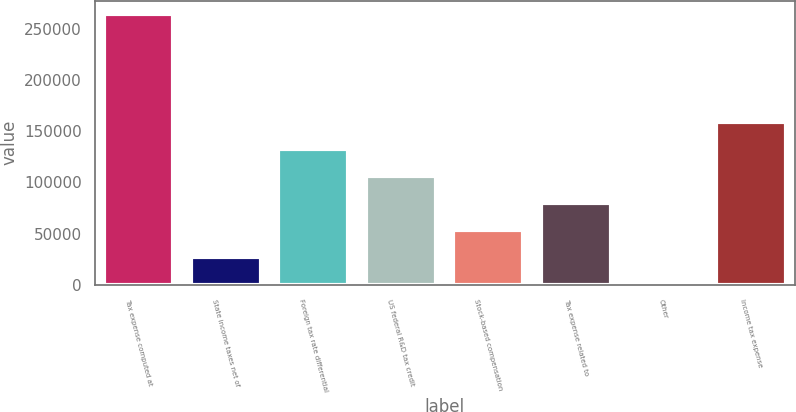Convert chart. <chart><loc_0><loc_0><loc_500><loc_500><bar_chart><fcel>Tax expense computed at<fcel>State income taxes net of<fcel>Foreign tax rate differential<fcel>US federal R&D tax credit<fcel>Stock-based compensation<fcel>Tax expense related to<fcel>Other<fcel>Income tax expense<nl><fcel>264192<fcel>26991.6<fcel>132414<fcel>106058<fcel>53347.2<fcel>79702.8<fcel>636<fcel>158770<nl></chart> 